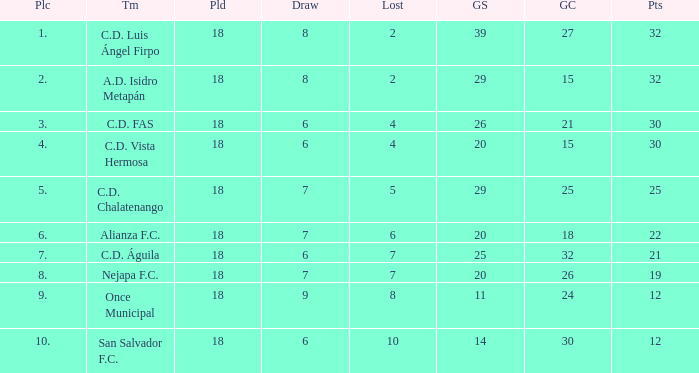What is the sum of draw with a lost smaller than 6, and a place of 5, and a goals scored less than 29? None. 